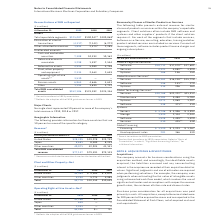According to International Business Machines's financial document, What is included in Client solutions? Client solutions often include IBM software and systems and other suppliers’ products if the client solution requires it.. The document states: "services within the company’s reportable segments. Client solutions often include IBM software and systems and other suppliers’ products if the client..." Also, What is included in Services? For each of the segments that include services, Software-as-a-Service, consulting, education, training and other product-related services are included as services.. The document states: "iers’ products if the client solution requires it. For each of the segments that include services, Software-as-a-Service, consulting, education, train..." Also, What is included in Software? For each of these segments, software includes product license charges and ongoing subscriptions.. The document states: "product-related services are included as services. For each of these segments, software includes product license charges and ongoing subscriptions...." Also, can you calculate: What is the average of Financing under Global Financing? To answer this question, I need to perform calculations using the financial data. The calculation is: (1,120+1,223+1,167 ) / 3, which equals 1170 (in millions). This is based on the information: "Financing $ 1,120 $ 1,223 $ 1,167 Financing $ 1,120 $ 1,223 $ 1,167 Financing $ 1,120 $ 1,223 $ 1,167..." The key data points involved are: 1,120, 1,167, 1,223. Also, can you calculate: What is the average of Used equipment sales? To answer this question, I need to perform calculations using the financial data. The calculation is: (281+366+530) / 3, which equals 392.33 (in millions). This is based on the information: "Used equipment sales 281 366 530 Used equipment sales 281 366 530 Used equipment sales 281 366 530..." The key data points involved are: 281, 366, 530. Also, can you calculate: What is the increase/ (decrease) in Used equipment sales from 2018 to 2019 Based on the calculation: 281-366 , the result is -85 (in millions). This is based on the information: "Used equipment sales 281 366 530 Used equipment sales 281 366 530..." The key data points involved are: 281, 366. 